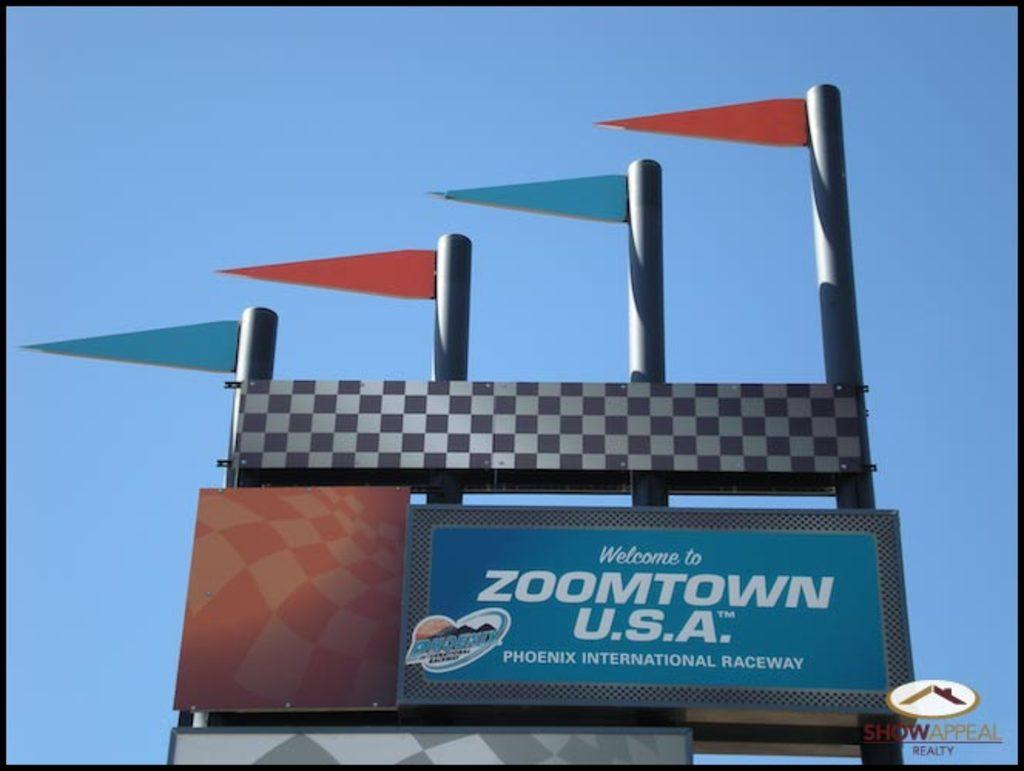<image>
Describe the image concisely. A billboard reads "Welcome to Zoomtown U.S.A.", which is in Phoenix. 